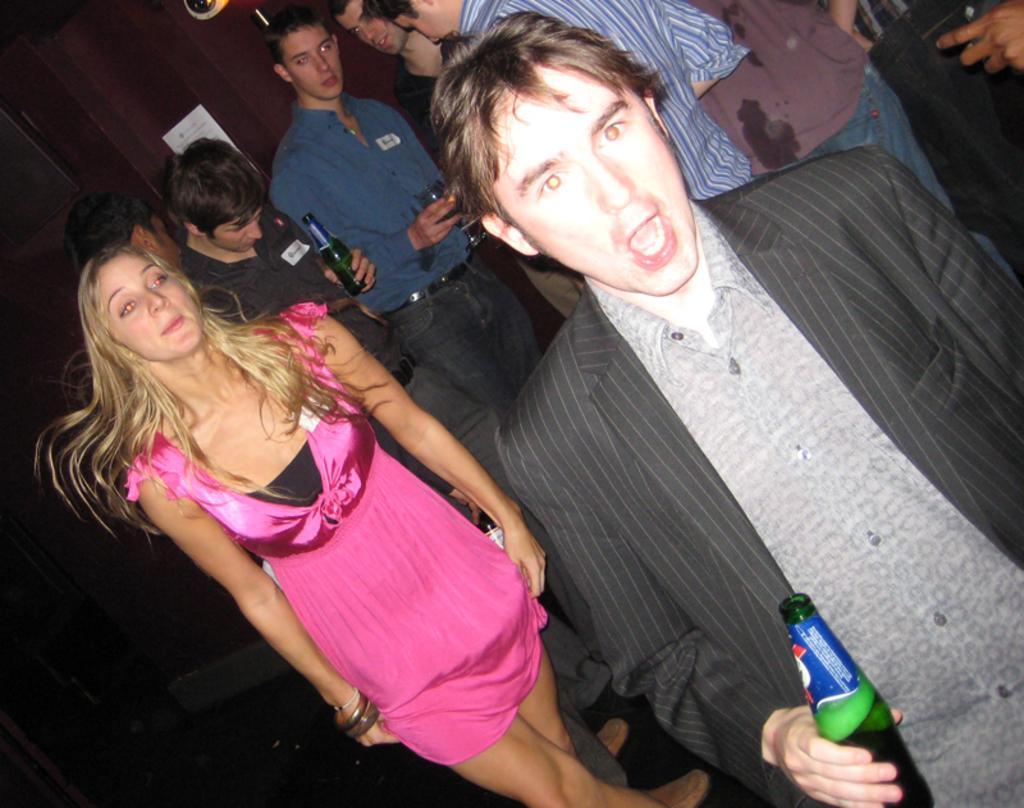Please provide a concise description of this image. A dark room where we have a group of people and a girl with pink and black frock and a guy who is wearing a coat having a bottle in his hand and behind the girl we have four people who are catching the bottles and the glasses. 